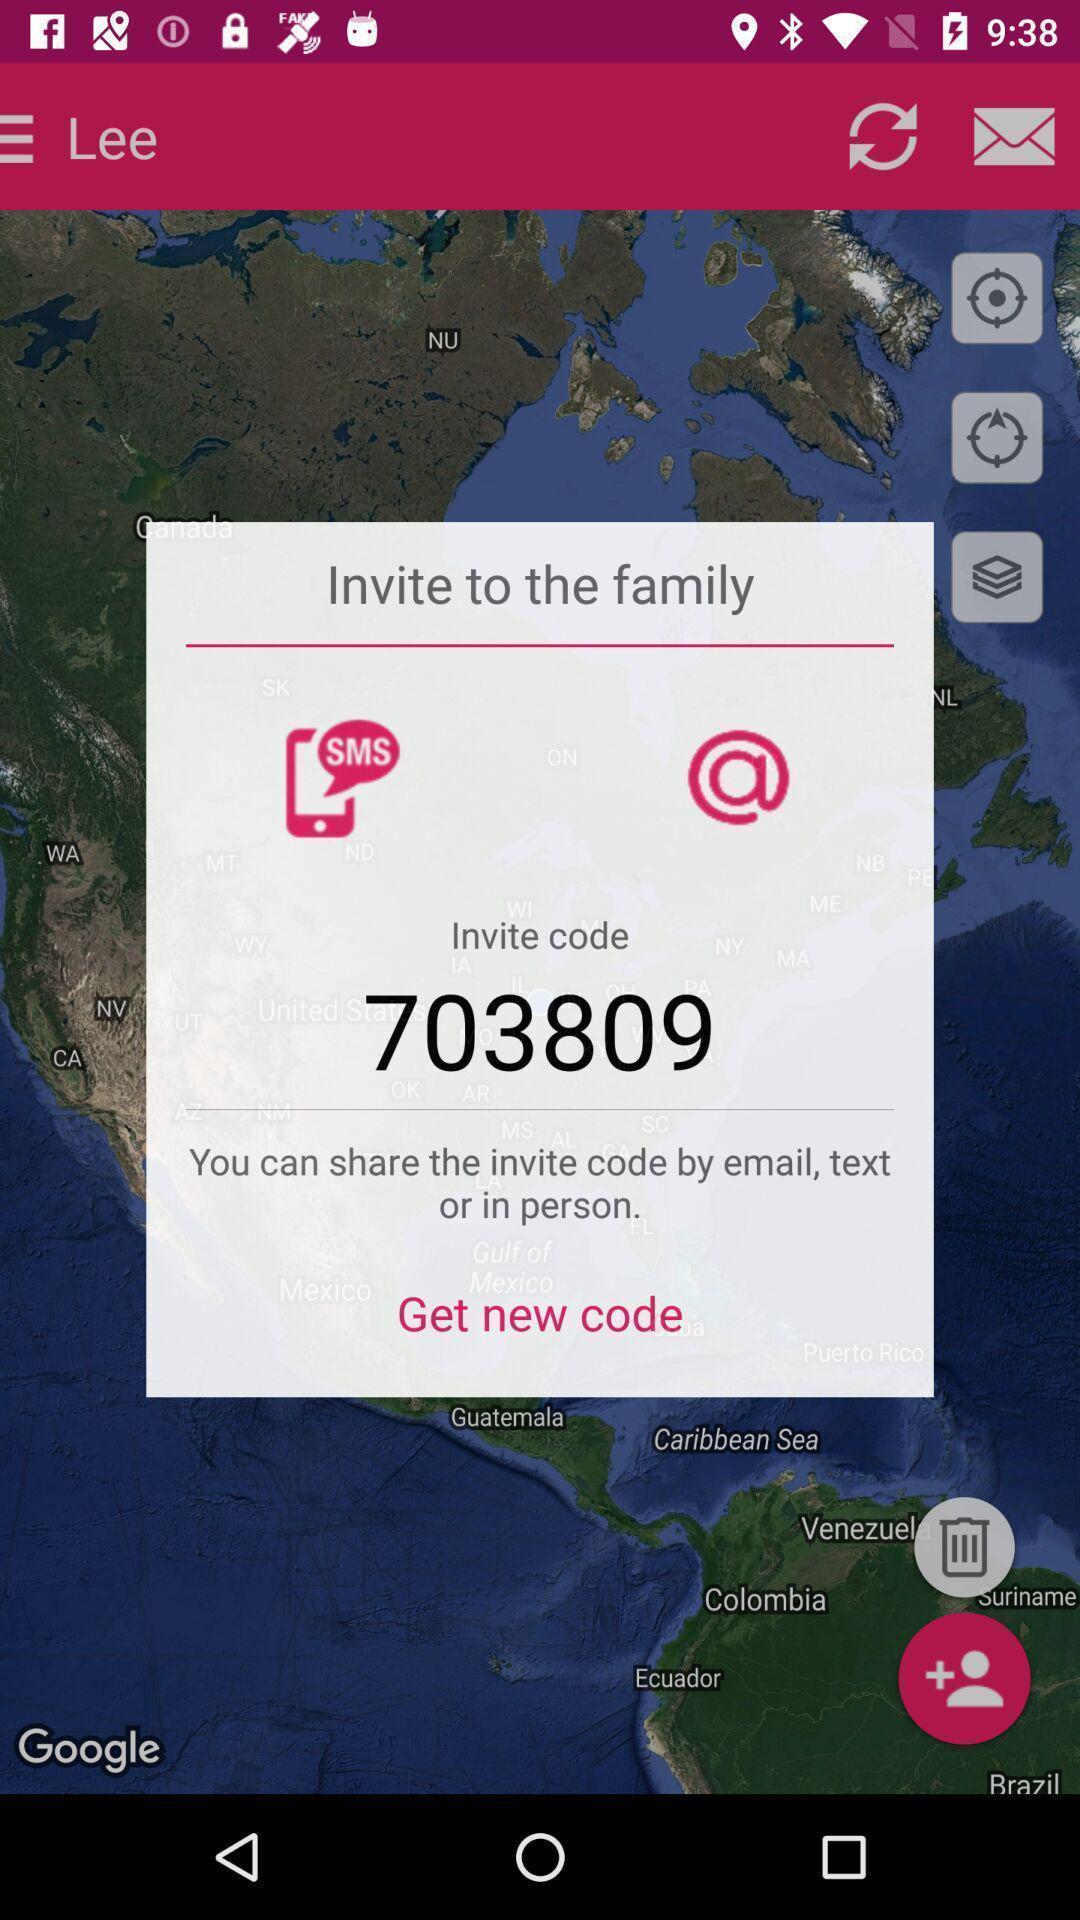Tell me about the visual elements in this screen capture. Pop-up to invite family via code in app. 